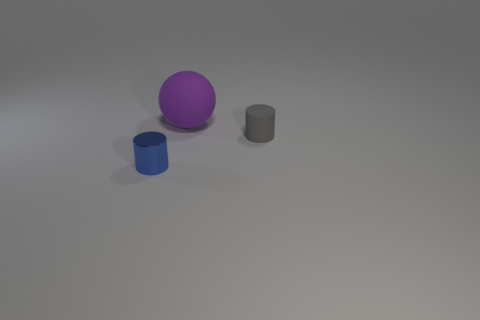Are there any other things that are the same size as the ball?
Your answer should be very brief. No. Is there anything else that is made of the same material as the blue cylinder?
Your answer should be compact. No. There is a cylinder behind the blue thing; how big is it?
Ensure brevity in your answer.  Small. There is a cylinder on the right side of the small blue shiny cylinder; is its color the same as the matte sphere?
Provide a short and direct response. No. What number of other metal things have the same shape as the purple thing?
Your response must be concise. 0. What number of objects are tiny cylinders on the left side of the purple rubber thing or blue metallic things that are in front of the large matte object?
Offer a very short reply. 1. How many green objects are metallic cylinders or large objects?
Make the answer very short. 0. There is a object that is behind the shiny thing and on the left side of the small gray object; what material is it?
Ensure brevity in your answer.  Rubber. Are the large purple ball and the blue cylinder made of the same material?
Make the answer very short. No. How many blue shiny cylinders have the same size as the sphere?
Your response must be concise. 0. 